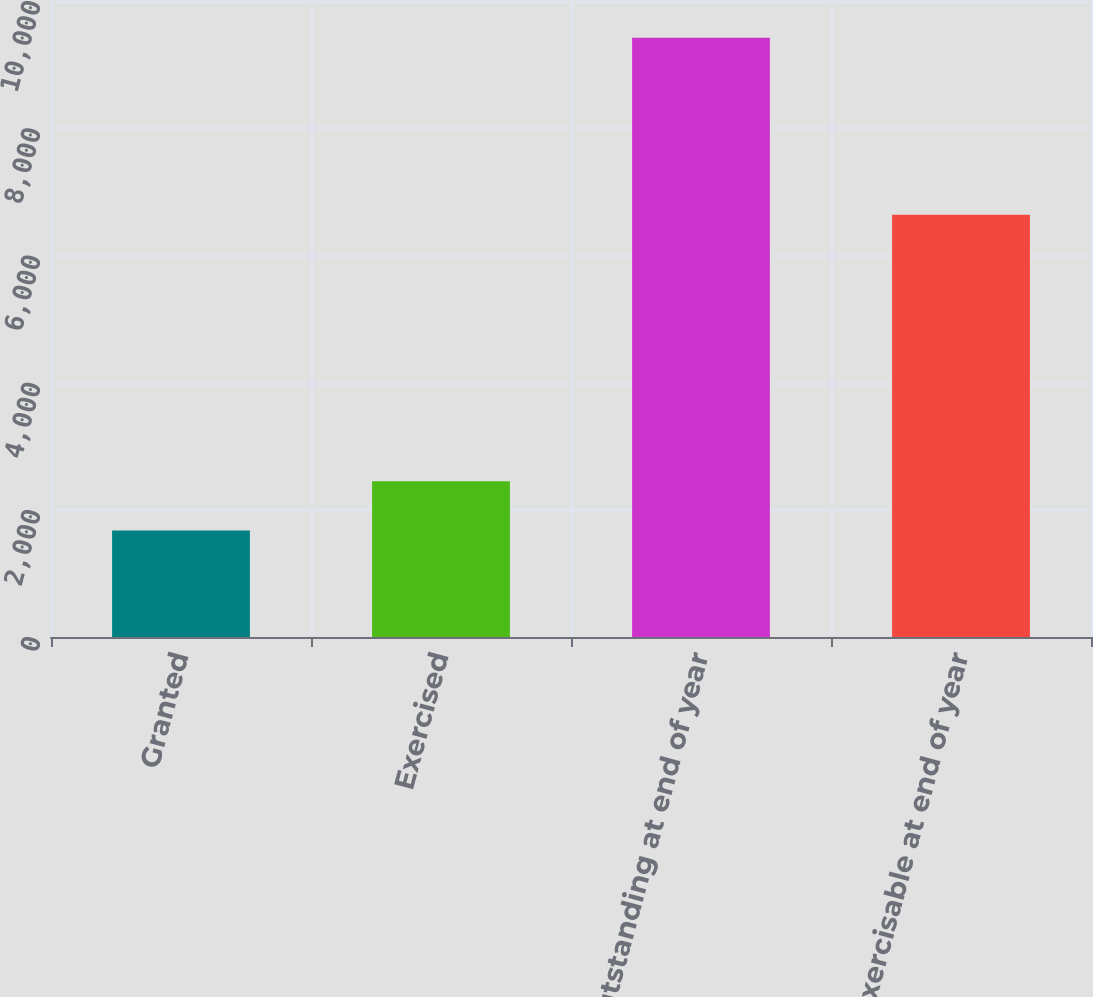<chart> <loc_0><loc_0><loc_500><loc_500><bar_chart><fcel>Granted<fcel>Exercised<fcel>Outstanding at end of year<fcel>Exercisable at end of year<nl><fcel>1676<fcel>2450.8<fcel>9424<fcel>6639<nl></chart> 